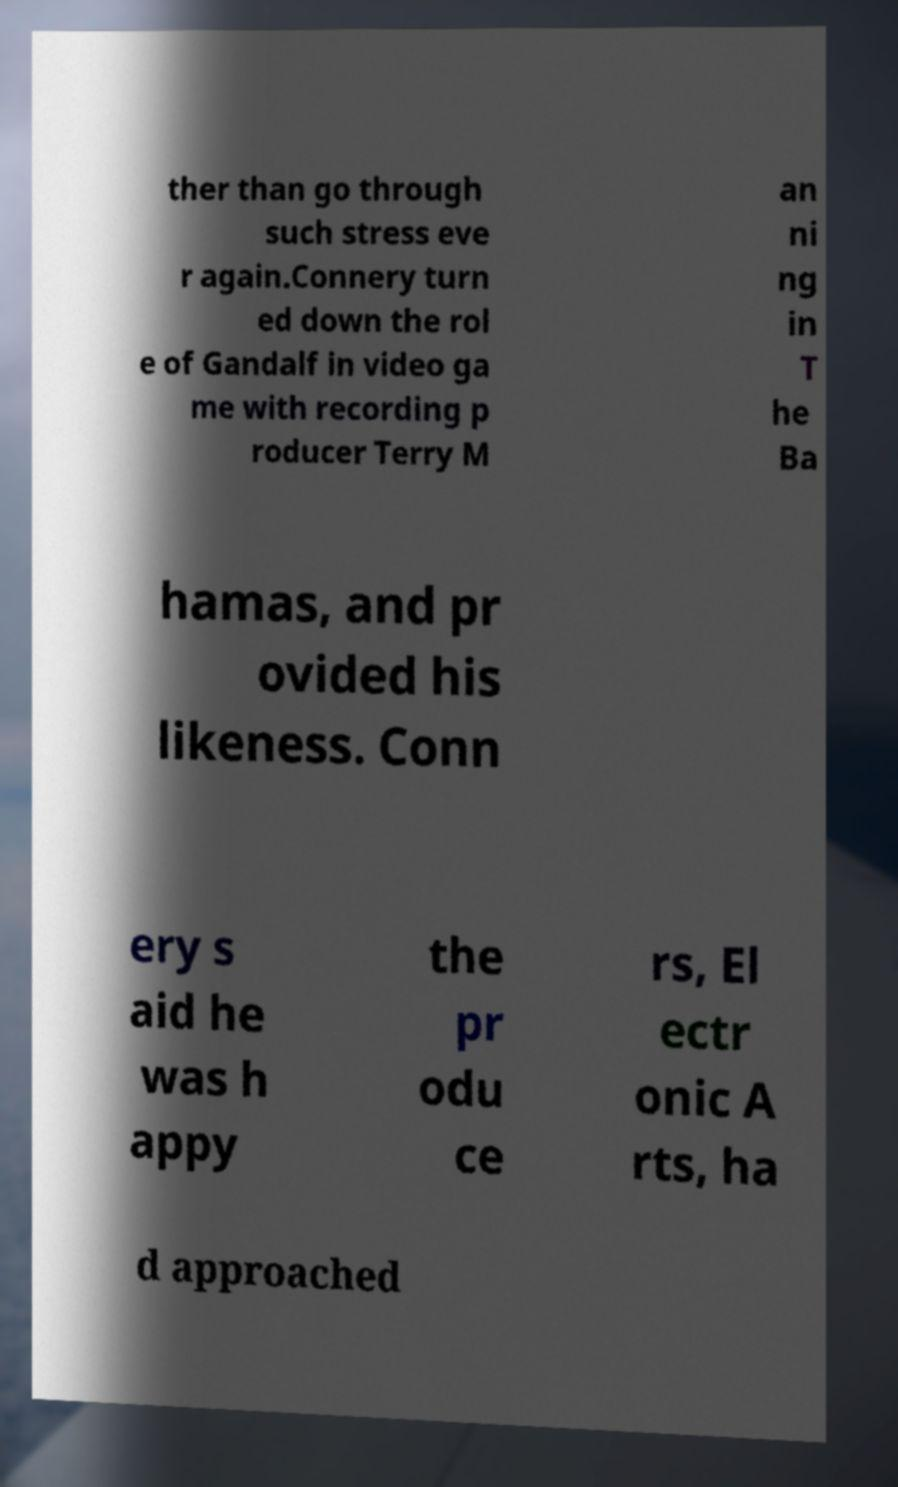What messages or text are displayed in this image? I need them in a readable, typed format. ther than go through such stress eve r again.Connery turn ed down the rol e of Gandalf in video ga me with recording p roducer Terry M an ni ng in T he Ba hamas, and pr ovided his likeness. Conn ery s aid he was h appy the pr odu ce rs, El ectr onic A rts, ha d approached 